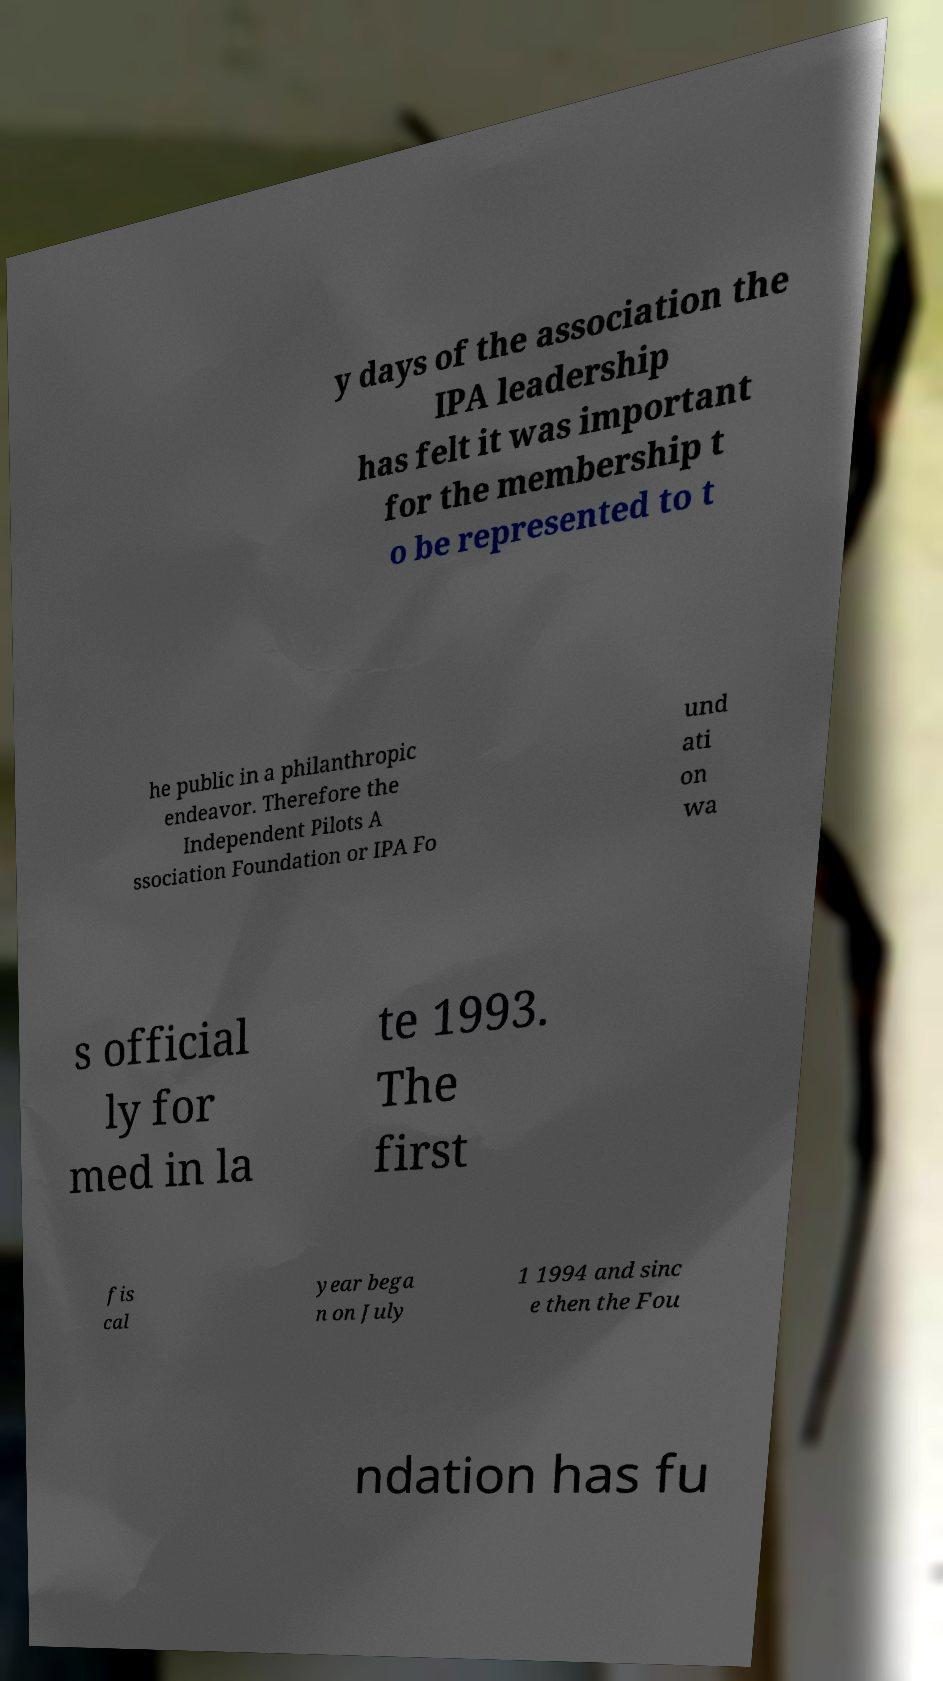For documentation purposes, I need the text within this image transcribed. Could you provide that? y days of the association the IPA leadership has felt it was important for the membership t o be represented to t he public in a philanthropic endeavor. Therefore the Independent Pilots A ssociation Foundation or IPA Fo und ati on wa s official ly for med in la te 1993. The first fis cal year bega n on July 1 1994 and sinc e then the Fou ndation has fu 